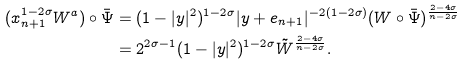<formula> <loc_0><loc_0><loc_500><loc_500>( x _ { n + 1 } ^ { 1 - 2 \sigma } W ^ { a } ) \circ \bar { \Psi } & = ( 1 - | y | ^ { 2 } ) ^ { 1 - 2 \sigma } | y + e _ { n + 1 } | ^ { - 2 ( 1 - 2 \sigma ) } ( W \circ \bar { \Psi } ) ^ { \frac { 2 - 4 \sigma } { n - 2 \sigma } } \\ & = 2 ^ { 2 \sigma - 1 } ( 1 - | y | ^ { 2 } ) ^ { 1 - 2 \sigma } \tilde { W } ^ { \frac { 2 - 4 \sigma } { n - 2 \sigma } } .</formula> 